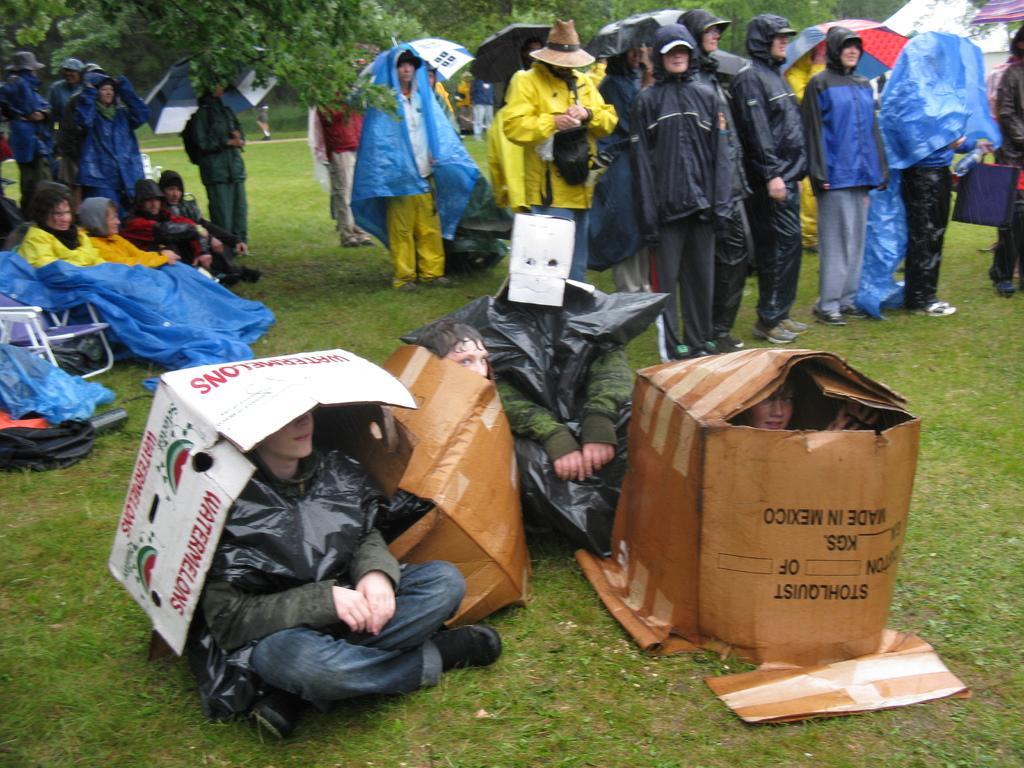Can you describe this image briefly? In this image we can see the group of people standing. There are many trees at the top most of the image. In this image few people are sitting. There is a grassy land in the image. 